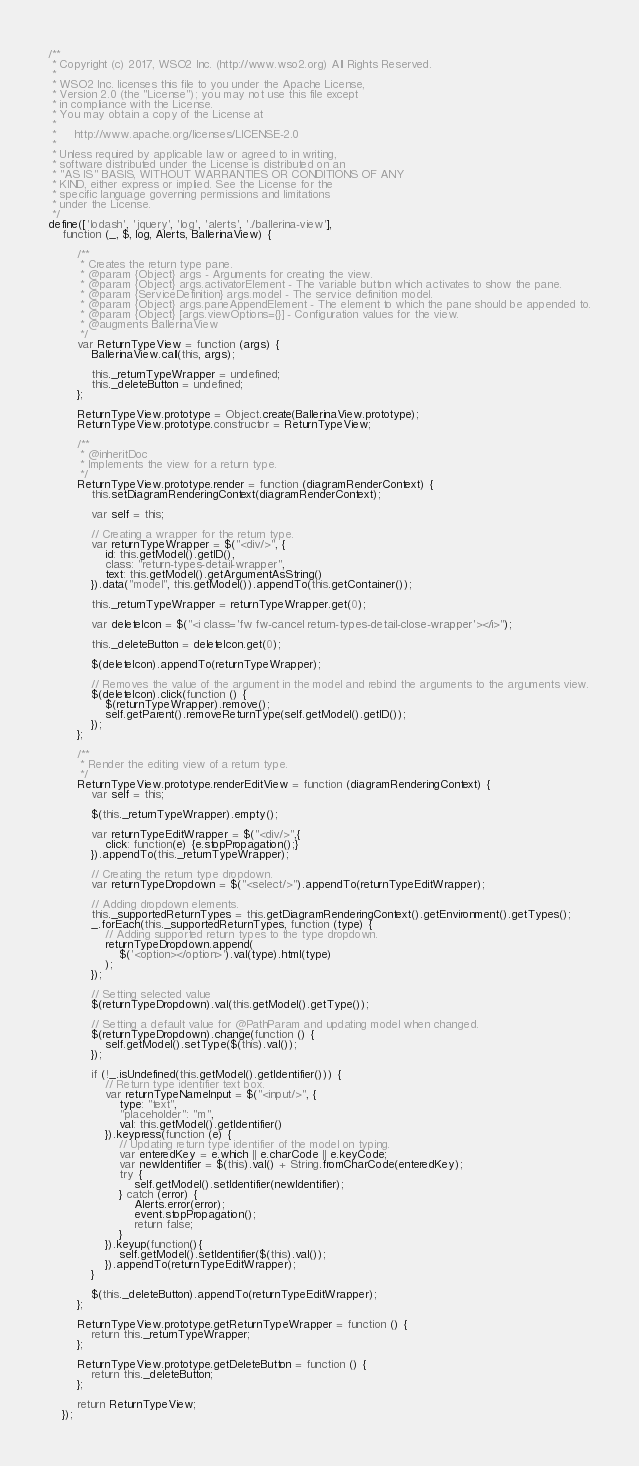Convert code to text. <code><loc_0><loc_0><loc_500><loc_500><_JavaScript_>/**
 * Copyright (c) 2017, WSO2 Inc. (http://www.wso2.org) All Rights Reserved.
 *
 * WSO2 Inc. licenses this file to you under the Apache License,
 * Version 2.0 (the "License"); you may not use this file except
 * in compliance with the License.
 * You may obtain a copy of the License at
 *
 *     http://www.apache.org/licenses/LICENSE-2.0
 *
 * Unless required by applicable law or agreed to in writing,
 * software distributed under the License is distributed on an
 * "AS IS" BASIS, WITHOUT WARRANTIES OR CONDITIONS OF ANY
 * KIND, either express or implied. See the License for the
 * specific language governing permissions and limitations
 * under the License.
 */
define(['lodash', 'jquery', 'log', 'alerts', './ballerina-view'],
    function (_, $, log, Alerts, BallerinaView) {

        /**
         * Creates the return type pane.
         * @param {Object} args - Arguments for creating the view.
         * @param {Object} args.activatorElement - The variable button which activates to show the pane.
         * @param {ServiceDefinition} args.model - The service definition model.
         * @param {Object} args.paneAppendElement - The element to which the pane should be appended to.
         * @param {Object} [args.viewOptions={}] - Configuration values for the view.
         * @augments BallerinaView
         */
        var ReturnTypeView = function (args) {
            BallerinaView.call(this, args);

            this._returnTypeWrapper = undefined;
            this._deleteButton = undefined;
        };

        ReturnTypeView.prototype = Object.create(BallerinaView.prototype);
        ReturnTypeView.prototype.constructor = ReturnTypeView;

        /**
         * @inheritDoc
         * Implements the view for a return type.
         */
        ReturnTypeView.prototype.render = function (diagramRenderContext) {
            this.setDiagramRenderingContext(diagramRenderContext);

            var self = this;

            // Creating a wrapper for the return type.
            var returnTypeWrapper = $("<div/>", {
                id: this.getModel().getID(),
                class: "return-types-detail-wrapper",
                text: this.getModel().getArgumentAsString()
            }).data("model", this.getModel()).appendTo(this.getContainer());

            this._returnTypeWrapper = returnTypeWrapper.get(0);

            var deleteIcon = $("<i class='fw fw-cancel return-types-detail-close-wrapper'></i>");

            this._deleteButton = deleteIcon.get(0);

            $(deleteIcon).appendTo(returnTypeWrapper);

            // Removes the value of the argument in the model and rebind the arguments to the arguments view.
            $(deleteIcon).click(function () {
                $(returnTypeWrapper).remove();
                self.getParent().removeReturnType(self.getModel().getID());
            });
        };

        /**
         * Render the editing view of a return type.
         */
        ReturnTypeView.prototype.renderEditView = function (diagramRenderingContext) {
            var self = this;

            $(this._returnTypeWrapper).empty();

            var returnTypeEditWrapper = $("<div/>",{
                click: function(e) {e.stopPropagation();}
            }).appendTo(this._returnTypeWrapper);

            // Creating the return type dropdown.
            var returnTypeDropdown = $("<select/>").appendTo(returnTypeEditWrapper);

            // Adding dropdown elements.
            this._supportedReturnTypes = this.getDiagramRenderingContext().getEnvironment().getTypes();
            _.forEach(this._supportedReturnTypes, function (type) {
                // Adding supported return types to the type dropdown.
                returnTypeDropdown.append(
                    $('<option></option>').val(type).html(type)
                );
            });

            // Setting selected value
            $(returnTypeDropdown).val(this.getModel().getType());

            // Setting a default value for @PathParam and updating model when changed.
            $(returnTypeDropdown).change(function () {
                self.getModel().setType($(this).val());
            });

            if (!_.isUndefined(this.getModel().getIdentifier())) {
                // Return type identifier text box.
                var returnTypeNameInput = $("<input/>", {
                    type: "text",
                    "placeholder": "m",
                    val: this.getModel().getIdentifier()
                }).keypress(function (e) {
                    // Updating return type identifier of the model on typing.
                    var enteredKey = e.which || e.charCode || e.keyCode;
                    var newIdentifier = $(this).val() + String.fromCharCode(enteredKey);
                    try {
                        self.getModel().setIdentifier(newIdentifier);
                    } catch (error) {
                        Alerts.error(error);
                        event.stopPropagation();
                        return false;
                    }
                }).keyup(function(){
                    self.getModel().setIdentifier($(this).val());
                }).appendTo(returnTypeEditWrapper);
            }

            $(this._deleteButton).appendTo(returnTypeEditWrapper);
        };

        ReturnTypeView.prototype.getReturnTypeWrapper = function () {
            return this._returnTypeWrapper;
        };

        ReturnTypeView.prototype.getDeleteButton = function () {
            return this._deleteButton;
        };

        return ReturnTypeView;
    });</code> 